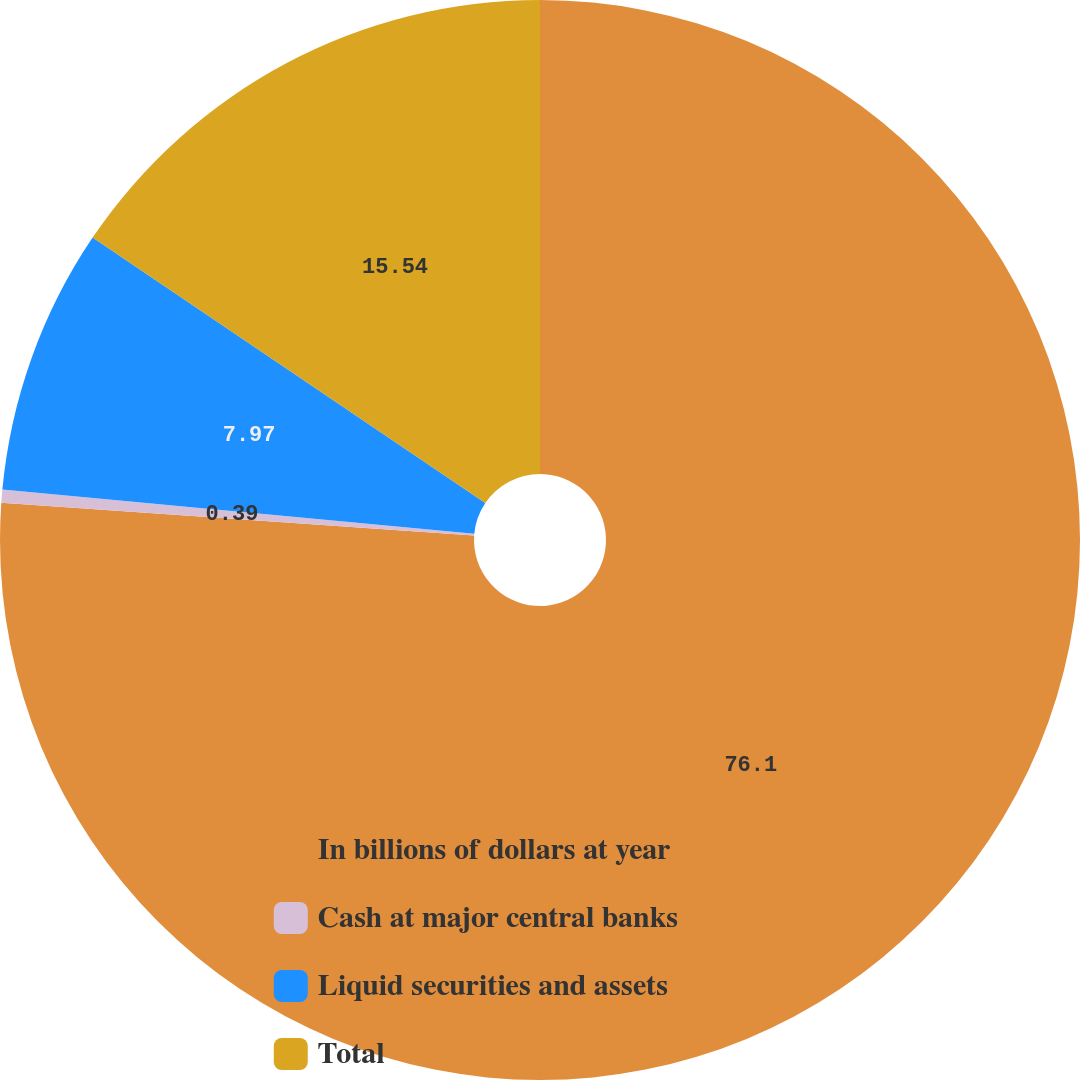<chart> <loc_0><loc_0><loc_500><loc_500><pie_chart><fcel>In billions of dollars at year<fcel>Cash at major central banks<fcel>Liquid securities and assets<fcel>Total<nl><fcel>76.1%<fcel>0.39%<fcel>7.97%<fcel>15.54%<nl></chart> 